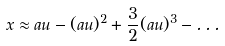<formula> <loc_0><loc_0><loc_500><loc_500>x \approx a u - ( a u ) ^ { 2 } + \frac { 3 } { 2 } ( a u ) ^ { 3 } - \dots</formula> 